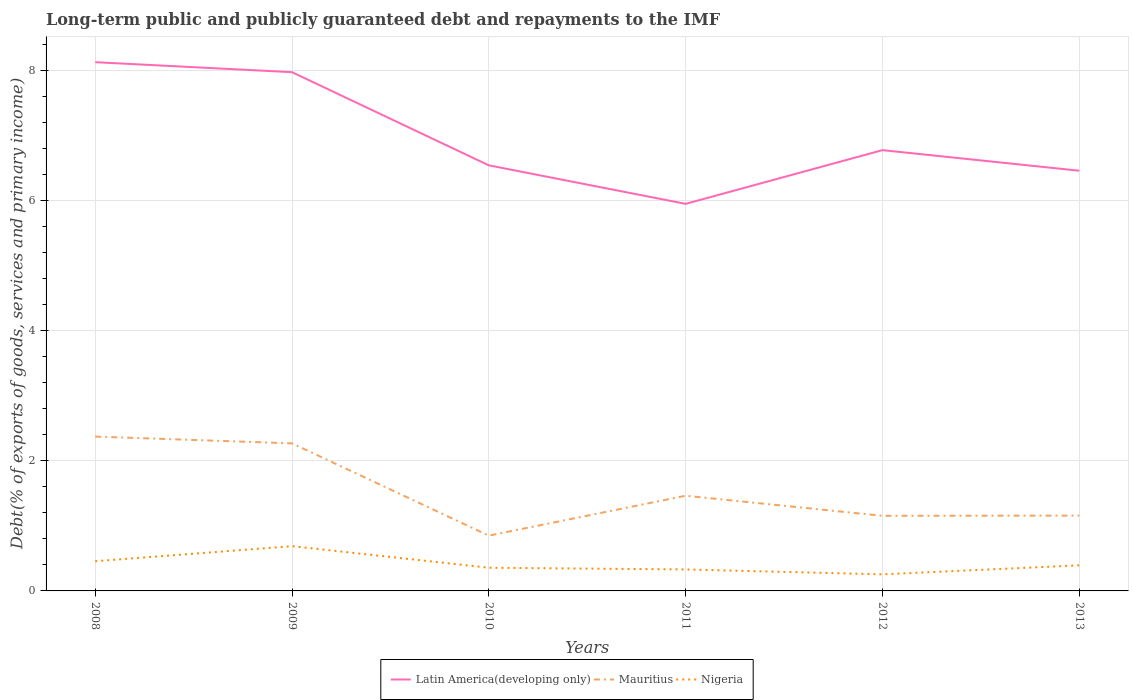Does the line corresponding to Latin America(developing only) intersect with the line corresponding to Mauritius?
Provide a short and direct response. No. Across all years, what is the maximum debt and repayments in Mauritius?
Give a very brief answer. 0.85. In which year was the debt and repayments in Latin America(developing only) maximum?
Make the answer very short. 2011. What is the total debt and repayments in Nigeria in the graph?
Your answer should be compact. 0.1. What is the difference between the highest and the second highest debt and repayments in Nigeria?
Keep it short and to the point. 0.43. Is the debt and repayments in Latin America(developing only) strictly greater than the debt and repayments in Mauritius over the years?
Offer a very short reply. No. How many lines are there?
Make the answer very short. 3. How many years are there in the graph?
Your answer should be compact. 6. Are the values on the major ticks of Y-axis written in scientific E-notation?
Keep it short and to the point. No. Where does the legend appear in the graph?
Keep it short and to the point. Bottom center. How many legend labels are there?
Keep it short and to the point. 3. How are the legend labels stacked?
Provide a short and direct response. Horizontal. What is the title of the graph?
Your answer should be compact. Long-term public and publicly guaranteed debt and repayments to the IMF. Does "Monaco" appear as one of the legend labels in the graph?
Provide a short and direct response. No. What is the label or title of the X-axis?
Give a very brief answer. Years. What is the label or title of the Y-axis?
Your answer should be very brief. Debt(% of exports of goods, services and primary income). What is the Debt(% of exports of goods, services and primary income) in Latin America(developing only) in 2008?
Keep it short and to the point. 8.13. What is the Debt(% of exports of goods, services and primary income) of Mauritius in 2008?
Provide a short and direct response. 2.37. What is the Debt(% of exports of goods, services and primary income) in Nigeria in 2008?
Make the answer very short. 0.46. What is the Debt(% of exports of goods, services and primary income) in Latin America(developing only) in 2009?
Keep it short and to the point. 7.97. What is the Debt(% of exports of goods, services and primary income) of Mauritius in 2009?
Give a very brief answer. 2.27. What is the Debt(% of exports of goods, services and primary income) of Nigeria in 2009?
Offer a terse response. 0.69. What is the Debt(% of exports of goods, services and primary income) of Latin America(developing only) in 2010?
Your answer should be compact. 6.54. What is the Debt(% of exports of goods, services and primary income) of Mauritius in 2010?
Offer a terse response. 0.85. What is the Debt(% of exports of goods, services and primary income) of Nigeria in 2010?
Your answer should be compact. 0.36. What is the Debt(% of exports of goods, services and primary income) of Latin America(developing only) in 2011?
Keep it short and to the point. 5.95. What is the Debt(% of exports of goods, services and primary income) of Mauritius in 2011?
Give a very brief answer. 1.46. What is the Debt(% of exports of goods, services and primary income) of Nigeria in 2011?
Your answer should be compact. 0.33. What is the Debt(% of exports of goods, services and primary income) in Latin America(developing only) in 2012?
Ensure brevity in your answer.  6.78. What is the Debt(% of exports of goods, services and primary income) in Mauritius in 2012?
Your answer should be compact. 1.15. What is the Debt(% of exports of goods, services and primary income) of Nigeria in 2012?
Your response must be concise. 0.25. What is the Debt(% of exports of goods, services and primary income) of Latin America(developing only) in 2013?
Give a very brief answer. 6.46. What is the Debt(% of exports of goods, services and primary income) of Mauritius in 2013?
Offer a very short reply. 1.16. What is the Debt(% of exports of goods, services and primary income) of Nigeria in 2013?
Ensure brevity in your answer.  0.39. Across all years, what is the maximum Debt(% of exports of goods, services and primary income) of Latin America(developing only)?
Give a very brief answer. 8.13. Across all years, what is the maximum Debt(% of exports of goods, services and primary income) in Mauritius?
Your response must be concise. 2.37. Across all years, what is the maximum Debt(% of exports of goods, services and primary income) of Nigeria?
Provide a succinct answer. 0.69. Across all years, what is the minimum Debt(% of exports of goods, services and primary income) of Latin America(developing only)?
Offer a terse response. 5.95. Across all years, what is the minimum Debt(% of exports of goods, services and primary income) of Mauritius?
Your answer should be compact. 0.85. Across all years, what is the minimum Debt(% of exports of goods, services and primary income) of Nigeria?
Ensure brevity in your answer.  0.25. What is the total Debt(% of exports of goods, services and primary income) in Latin America(developing only) in the graph?
Ensure brevity in your answer.  41.83. What is the total Debt(% of exports of goods, services and primary income) in Mauritius in the graph?
Keep it short and to the point. 9.27. What is the total Debt(% of exports of goods, services and primary income) of Nigeria in the graph?
Offer a very short reply. 2.48. What is the difference between the Debt(% of exports of goods, services and primary income) in Latin America(developing only) in 2008 and that in 2009?
Give a very brief answer. 0.15. What is the difference between the Debt(% of exports of goods, services and primary income) of Mauritius in 2008 and that in 2009?
Your response must be concise. 0.1. What is the difference between the Debt(% of exports of goods, services and primary income) in Nigeria in 2008 and that in 2009?
Offer a very short reply. -0.23. What is the difference between the Debt(% of exports of goods, services and primary income) of Latin America(developing only) in 2008 and that in 2010?
Your response must be concise. 1.59. What is the difference between the Debt(% of exports of goods, services and primary income) in Mauritius in 2008 and that in 2010?
Keep it short and to the point. 1.52. What is the difference between the Debt(% of exports of goods, services and primary income) in Nigeria in 2008 and that in 2010?
Ensure brevity in your answer.  0.1. What is the difference between the Debt(% of exports of goods, services and primary income) of Latin America(developing only) in 2008 and that in 2011?
Your response must be concise. 2.18. What is the difference between the Debt(% of exports of goods, services and primary income) in Mauritius in 2008 and that in 2011?
Provide a short and direct response. 0.91. What is the difference between the Debt(% of exports of goods, services and primary income) of Nigeria in 2008 and that in 2011?
Keep it short and to the point. 0.13. What is the difference between the Debt(% of exports of goods, services and primary income) of Latin America(developing only) in 2008 and that in 2012?
Ensure brevity in your answer.  1.35. What is the difference between the Debt(% of exports of goods, services and primary income) of Mauritius in 2008 and that in 2012?
Offer a very short reply. 1.22. What is the difference between the Debt(% of exports of goods, services and primary income) of Nigeria in 2008 and that in 2012?
Make the answer very short. 0.2. What is the difference between the Debt(% of exports of goods, services and primary income) of Latin America(developing only) in 2008 and that in 2013?
Your response must be concise. 1.67. What is the difference between the Debt(% of exports of goods, services and primary income) of Mauritius in 2008 and that in 2013?
Your answer should be compact. 1.21. What is the difference between the Debt(% of exports of goods, services and primary income) in Nigeria in 2008 and that in 2013?
Your answer should be very brief. 0.06. What is the difference between the Debt(% of exports of goods, services and primary income) of Latin America(developing only) in 2009 and that in 2010?
Offer a terse response. 1.43. What is the difference between the Debt(% of exports of goods, services and primary income) in Mauritius in 2009 and that in 2010?
Offer a very short reply. 1.42. What is the difference between the Debt(% of exports of goods, services and primary income) in Nigeria in 2009 and that in 2010?
Your answer should be very brief. 0.33. What is the difference between the Debt(% of exports of goods, services and primary income) of Latin America(developing only) in 2009 and that in 2011?
Offer a terse response. 2.02. What is the difference between the Debt(% of exports of goods, services and primary income) of Mauritius in 2009 and that in 2011?
Give a very brief answer. 0.81. What is the difference between the Debt(% of exports of goods, services and primary income) in Nigeria in 2009 and that in 2011?
Give a very brief answer. 0.36. What is the difference between the Debt(% of exports of goods, services and primary income) of Latin America(developing only) in 2009 and that in 2012?
Provide a short and direct response. 1.2. What is the difference between the Debt(% of exports of goods, services and primary income) of Mauritius in 2009 and that in 2012?
Your answer should be compact. 1.11. What is the difference between the Debt(% of exports of goods, services and primary income) of Nigeria in 2009 and that in 2012?
Provide a short and direct response. 0.43. What is the difference between the Debt(% of exports of goods, services and primary income) in Latin America(developing only) in 2009 and that in 2013?
Your response must be concise. 1.51. What is the difference between the Debt(% of exports of goods, services and primary income) of Mauritius in 2009 and that in 2013?
Your answer should be very brief. 1.11. What is the difference between the Debt(% of exports of goods, services and primary income) in Nigeria in 2009 and that in 2013?
Ensure brevity in your answer.  0.29. What is the difference between the Debt(% of exports of goods, services and primary income) in Latin America(developing only) in 2010 and that in 2011?
Give a very brief answer. 0.59. What is the difference between the Debt(% of exports of goods, services and primary income) in Mauritius in 2010 and that in 2011?
Offer a terse response. -0.61. What is the difference between the Debt(% of exports of goods, services and primary income) of Nigeria in 2010 and that in 2011?
Offer a very short reply. 0.03. What is the difference between the Debt(% of exports of goods, services and primary income) in Latin America(developing only) in 2010 and that in 2012?
Give a very brief answer. -0.23. What is the difference between the Debt(% of exports of goods, services and primary income) in Mauritius in 2010 and that in 2012?
Provide a short and direct response. -0.3. What is the difference between the Debt(% of exports of goods, services and primary income) in Nigeria in 2010 and that in 2012?
Your answer should be compact. 0.1. What is the difference between the Debt(% of exports of goods, services and primary income) of Latin America(developing only) in 2010 and that in 2013?
Provide a short and direct response. 0.08. What is the difference between the Debt(% of exports of goods, services and primary income) of Mauritius in 2010 and that in 2013?
Make the answer very short. -0.31. What is the difference between the Debt(% of exports of goods, services and primary income) in Nigeria in 2010 and that in 2013?
Make the answer very short. -0.04. What is the difference between the Debt(% of exports of goods, services and primary income) in Latin America(developing only) in 2011 and that in 2012?
Give a very brief answer. -0.83. What is the difference between the Debt(% of exports of goods, services and primary income) of Mauritius in 2011 and that in 2012?
Your response must be concise. 0.31. What is the difference between the Debt(% of exports of goods, services and primary income) in Nigeria in 2011 and that in 2012?
Provide a succinct answer. 0.08. What is the difference between the Debt(% of exports of goods, services and primary income) of Latin America(developing only) in 2011 and that in 2013?
Your response must be concise. -0.51. What is the difference between the Debt(% of exports of goods, services and primary income) of Mauritius in 2011 and that in 2013?
Offer a terse response. 0.3. What is the difference between the Debt(% of exports of goods, services and primary income) in Nigeria in 2011 and that in 2013?
Provide a short and direct response. -0.06. What is the difference between the Debt(% of exports of goods, services and primary income) in Latin America(developing only) in 2012 and that in 2013?
Ensure brevity in your answer.  0.32. What is the difference between the Debt(% of exports of goods, services and primary income) in Mauritius in 2012 and that in 2013?
Provide a short and direct response. -0. What is the difference between the Debt(% of exports of goods, services and primary income) of Nigeria in 2012 and that in 2013?
Keep it short and to the point. -0.14. What is the difference between the Debt(% of exports of goods, services and primary income) in Latin America(developing only) in 2008 and the Debt(% of exports of goods, services and primary income) in Mauritius in 2009?
Provide a short and direct response. 5.86. What is the difference between the Debt(% of exports of goods, services and primary income) of Latin America(developing only) in 2008 and the Debt(% of exports of goods, services and primary income) of Nigeria in 2009?
Your answer should be compact. 7.44. What is the difference between the Debt(% of exports of goods, services and primary income) in Mauritius in 2008 and the Debt(% of exports of goods, services and primary income) in Nigeria in 2009?
Your answer should be very brief. 1.68. What is the difference between the Debt(% of exports of goods, services and primary income) of Latin America(developing only) in 2008 and the Debt(% of exports of goods, services and primary income) of Mauritius in 2010?
Offer a very short reply. 7.28. What is the difference between the Debt(% of exports of goods, services and primary income) of Latin America(developing only) in 2008 and the Debt(% of exports of goods, services and primary income) of Nigeria in 2010?
Offer a terse response. 7.77. What is the difference between the Debt(% of exports of goods, services and primary income) of Mauritius in 2008 and the Debt(% of exports of goods, services and primary income) of Nigeria in 2010?
Your response must be concise. 2.02. What is the difference between the Debt(% of exports of goods, services and primary income) of Latin America(developing only) in 2008 and the Debt(% of exports of goods, services and primary income) of Mauritius in 2011?
Your answer should be very brief. 6.66. What is the difference between the Debt(% of exports of goods, services and primary income) in Latin America(developing only) in 2008 and the Debt(% of exports of goods, services and primary income) in Nigeria in 2011?
Ensure brevity in your answer.  7.8. What is the difference between the Debt(% of exports of goods, services and primary income) in Mauritius in 2008 and the Debt(% of exports of goods, services and primary income) in Nigeria in 2011?
Make the answer very short. 2.04. What is the difference between the Debt(% of exports of goods, services and primary income) in Latin America(developing only) in 2008 and the Debt(% of exports of goods, services and primary income) in Mauritius in 2012?
Keep it short and to the point. 6.97. What is the difference between the Debt(% of exports of goods, services and primary income) of Latin America(developing only) in 2008 and the Debt(% of exports of goods, services and primary income) of Nigeria in 2012?
Your answer should be very brief. 7.87. What is the difference between the Debt(% of exports of goods, services and primary income) of Mauritius in 2008 and the Debt(% of exports of goods, services and primary income) of Nigeria in 2012?
Your answer should be very brief. 2.12. What is the difference between the Debt(% of exports of goods, services and primary income) of Latin America(developing only) in 2008 and the Debt(% of exports of goods, services and primary income) of Mauritius in 2013?
Offer a very short reply. 6.97. What is the difference between the Debt(% of exports of goods, services and primary income) of Latin America(developing only) in 2008 and the Debt(% of exports of goods, services and primary income) of Nigeria in 2013?
Offer a terse response. 7.73. What is the difference between the Debt(% of exports of goods, services and primary income) in Mauritius in 2008 and the Debt(% of exports of goods, services and primary income) in Nigeria in 2013?
Ensure brevity in your answer.  1.98. What is the difference between the Debt(% of exports of goods, services and primary income) in Latin America(developing only) in 2009 and the Debt(% of exports of goods, services and primary income) in Mauritius in 2010?
Offer a very short reply. 7.12. What is the difference between the Debt(% of exports of goods, services and primary income) of Latin America(developing only) in 2009 and the Debt(% of exports of goods, services and primary income) of Nigeria in 2010?
Provide a short and direct response. 7.62. What is the difference between the Debt(% of exports of goods, services and primary income) of Mauritius in 2009 and the Debt(% of exports of goods, services and primary income) of Nigeria in 2010?
Your answer should be very brief. 1.91. What is the difference between the Debt(% of exports of goods, services and primary income) of Latin America(developing only) in 2009 and the Debt(% of exports of goods, services and primary income) of Mauritius in 2011?
Ensure brevity in your answer.  6.51. What is the difference between the Debt(% of exports of goods, services and primary income) of Latin America(developing only) in 2009 and the Debt(% of exports of goods, services and primary income) of Nigeria in 2011?
Provide a short and direct response. 7.64. What is the difference between the Debt(% of exports of goods, services and primary income) in Mauritius in 2009 and the Debt(% of exports of goods, services and primary income) in Nigeria in 2011?
Offer a terse response. 1.94. What is the difference between the Debt(% of exports of goods, services and primary income) in Latin America(developing only) in 2009 and the Debt(% of exports of goods, services and primary income) in Mauritius in 2012?
Provide a succinct answer. 6.82. What is the difference between the Debt(% of exports of goods, services and primary income) of Latin America(developing only) in 2009 and the Debt(% of exports of goods, services and primary income) of Nigeria in 2012?
Your answer should be compact. 7.72. What is the difference between the Debt(% of exports of goods, services and primary income) in Mauritius in 2009 and the Debt(% of exports of goods, services and primary income) in Nigeria in 2012?
Give a very brief answer. 2.01. What is the difference between the Debt(% of exports of goods, services and primary income) in Latin America(developing only) in 2009 and the Debt(% of exports of goods, services and primary income) in Mauritius in 2013?
Provide a succinct answer. 6.82. What is the difference between the Debt(% of exports of goods, services and primary income) of Latin America(developing only) in 2009 and the Debt(% of exports of goods, services and primary income) of Nigeria in 2013?
Provide a short and direct response. 7.58. What is the difference between the Debt(% of exports of goods, services and primary income) of Mauritius in 2009 and the Debt(% of exports of goods, services and primary income) of Nigeria in 2013?
Keep it short and to the point. 1.88. What is the difference between the Debt(% of exports of goods, services and primary income) of Latin America(developing only) in 2010 and the Debt(% of exports of goods, services and primary income) of Mauritius in 2011?
Make the answer very short. 5.08. What is the difference between the Debt(% of exports of goods, services and primary income) of Latin America(developing only) in 2010 and the Debt(% of exports of goods, services and primary income) of Nigeria in 2011?
Provide a short and direct response. 6.21. What is the difference between the Debt(% of exports of goods, services and primary income) in Mauritius in 2010 and the Debt(% of exports of goods, services and primary income) in Nigeria in 2011?
Provide a succinct answer. 0.52. What is the difference between the Debt(% of exports of goods, services and primary income) of Latin America(developing only) in 2010 and the Debt(% of exports of goods, services and primary income) of Mauritius in 2012?
Your answer should be compact. 5.39. What is the difference between the Debt(% of exports of goods, services and primary income) of Latin America(developing only) in 2010 and the Debt(% of exports of goods, services and primary income) of Nigeria in 2012?
Your answer should be compact. 6.29. What is the difference between the Debt(% of exports of goods, services and primary income) of Mauritius in 2010 and the Debt(% of exports of goods, services and primary income) of Nigeria in 2012?
Your answer should be compact. 0.59. What is the difference between the Debt(% of exports of goods, services and primary income) of Latin America(developing only) in 2010 and the Debt(% of exports of goods, services and primary income) of Mauritius in 2013?
Your answer should be very brief. 5.38. What is the difference between the Debt(% of exports of goods, services and primary income) of Latin America(developing only) in 2010 and the Debt(% of exports of goods, services and primary income) of Nigeria in 2013?
Make the answer very short. 6.15. What is the difference between the Debt(% of exports of goods, services and primary income) of Mauritius in 2010 and the Debt(% of exports of goods, services and primary income) of Nigeria in 2013?
Offer a terse response. 0.46. What is the difference between the Debt(% of exports of goods, services and primary income) of Latin America(developing only) in 2011 and the Debt(% of exports of goods, services and primary income) of Mauritius in 2012?
Make the answer very short. 4.8. What is the difference between the Debt(% of exports of goods, services and primary income) in Latin America(developing only) in 2011 and the Debt(% of exports of goods, services and primary income) in Nigeria in 2012?
Make the answer very short. 5.69. What is the difference between the Debt(% of exports of goods, services and primary income) of Mauritius in 2011 and the Debt(% of exports of goods, services and primary income) of Nigeria in 2012?
Ensure brevity in your answer.  1.21. What is the difference between the Debt(% of exports of goods, services and primary income) of Latin America(developing only) in 2011 and the Debt(% of exports of goods, services and primary income) of Mauritius in 2013?
Offer a terse response. 4.79. What is the difference between the Debt(% of exports of goods, services and primary income) of Latin America(developing only) in 2011 and the Debt(% of exports of goods, services and primary income) of Nigeria in 2013?
Offer a very short reply. 5.56. What is the difference between the Debt(% of exports of goods, services and primary income) of Mauritius in 2011 and the Debt(% of exports of goods, services and primary income) of Nigeria in 2013?
Make the answer very short. 1.07. What is the difference between the Debt(% of exports of goods, services and primary income) of Latin America(developing only) in 2012 and the Debt(% of exports of goods, services and primary income) of Mauritius in 2013?
Give a very brief answer. 5.62. What is the difference between the Debt(% of exports of goods, services and primary income) in Latin America(developing only) in 2012 and the Debt(% of exports of goods, services and primary income) in Nigeria in 2013?
Provide a short and direct response. 6.38. What is the difference between the Debt(% of exports of goods, services and primary income) in Mauritius in 2012 and the Debt(% of exports of goods, services and primary income) in Nigeria in 2013?
Provide a succinct answer. 0.76. What is the average Debt(% of exports of goods, services and primary income) of Latin America(developing only) per year?
Provide a succinct answer. 6.97. What is the average Debt(% of exports of goods, services and primary income) in Mauritius per year?
Your response must be concise. 1.54. What is the average Debt(% of exports of goods, services and primary income) in Nigeria per year?
Give a very brief answer. 0.41. In the year 2008, what is the difference between the Debt(% of exports of goods, services and primary income) in Latin America(developing only) and Debt(% of exports of goods, services and primary income) in Mauritius?
Keep it short and to the point. 5.76. In the year 2008, what is the difference between the Debt(% of exports of goods, services and primary income) in Latin America(developing only) and Debt(% of exports of goods, services and primary income) in Nigeria?
Offer a very short reply. 7.67. In the year 2008, what is the difference between the Debt(% of exports of goods, services and primary income) in Mauritius and Debt(% of exports of goods, services and primary income) in Nigeria?
Your answer should be very brief. 1.92. In the year 2009, what is the difference between the Debt(% of exports of goods, services and primary income) in Latin America(developing only) and Debt(% of exports of goods, services and primary income) in Mauritius?
Your response must be concise. 5.71. In the year 2009, what is the difference between the Debt(% of exports of goods, services and primary income) in Latin America(developing only) and Debt(% of exports of goods, services and primary income) in Nigeria?
Make the answer very short. 7.29. In the year 2009, what is the difference between the Debt(% of exports of goods, services and primary income) in Mauritius and Debt(% of exports of goods, services and primary income) in Nigeria?
Ensure brevity in your answer.  1.58. In the year 2010, what is the difference between the Debt(% of exports of goods, services and primary income) in Latin America(developing only) and Debt(% of exports of goods, services and primary income) in Mauritius?
Your response must be concise. 5.69. In the year 2010, what is the difference between the Debt(% of exports of goods, services and primary income) in Latin America(developing only) and Debt(% of exports of goods, services and primary income) in Nigeria?
Provide a succinct answer. 6.19. In the year 2010, what is the difference between the Debt(% of exports of goods, services and primary income) in Mauritius and Debt(% of exports of goods, services and primary income) in Nigeria?
Your response must be concise. 0.49. In the year 2011, what is the difference between the Debt(% of exports of goods, services and primary income) in Latin America(developing only) and Debt(% of exports of goods, services and primary income) in Mauritius?
Offer a very short reply. 4.49. In the year 2011, what is the difference between the Debt(% of exports of goods, services and primary income) of Latin America(developing only) and Debt(% of exports of goods, services and primary income) of Nigeria?
Offer a very short reply. 5.62. In the year 2011, what is the difference between the Debt(% of exports of goods, services and primary income) of Mauritius and Debt(% of exports of goods, services and primary income) of Nigeria?
Make the answer very short. 1.13. In the year 2012, what is the difference between the Debt(% of exports of goods, services and primary income) of Latin America(developing only) and Debt(% of exports of goods, services and primary income) of Mauritius?
Your answer should be very brief. 5.62. In the year 2012, what is the difference between the Debt(% of exports of goods, services and primary income) in Latin America(developing only) and Debt(% of exports of goods, services and primary income) in Nigeria?
Offer a terse response. 6.52. In the year 2012, what is the difference between the Debt(% of exports of goods, services and primary income) of Mauritius and Debt(% of exports of goods, services and primary income) of Nigeria?
Give a very brief answer. 0.9. In the year 2013, what is the difference between the Debt(% of exports of goods, services and primary income) in Latin America(developing only) and Debt(% of exports of goods, services and primary income) in Mauritius?
Your answer should be compact. 5.3. In the year 2013, what is the difference between the Debt(% of exports of goods, services and primary income) in Latin America(developing only) and Debt(% of exports of goods, services and primary income) in Nigeria?
Make the answer very short. 6.07. In the year 2013, what is the difference between the Debt(% of exports of goods, services and primary income) in Mauritius and Debt(% of exports of goods, services and primary income) in Nigeria?
Offer a very short reply. 0.76. What is the ratio of the Debt(% of exports of goods, services and primary income) in Latin America(developing only) in 2008 to that in 2009?
Make the answer very short. 1.02. What is the ratio of the Debt(% of exports of goods, services and primary income) in Mauritius in 2008 to that in 2009?
Your answer should be compact. 1.05. What is the ratio of the Debt(% of exports of goods, services and primary income) in Nigeria in 2008 to that in 2009?
Your response must be concise. 0.66. What is the ratio of the Debt(% of exports of goods, services and primary income) of Latin America(developing only) in 2008 to that in 2010?
Offer a very short reply. 1.24. What is the ratio of the Debt(% of exports of goods, services and primary income) of Mauritius in 2008 to that in 2010?
Give a very brief answer. 2.79. What is the ratio of the Debt(% of exports of goods, services and primary income) in Nigeria in 2008 to that in 2010?
Your answer should be very brief. 1.28. What is the ratio of the Debt(% of exports of goods, services and primary income) of Latin America(developing only) in 2008 to that in 2011?
Give a very brief answer. 1.37. What is the ratio of the Debt(% of exports of goods, services and primary income) in Mauritius in 2008 to that in 2011?
Ensure brevity in your answer.  1.62. What is the ratio of the Debt(% of exports of goods, services and primary income) of Nigeria in 2008 to that in 2011?
Your answer should be compact. 1.38. What is the ratio of the Debt(% of exports of goods, services and primary income) of Latin America(developing only) in 2008 to that in 2012?
Offer a terse response. 1.2. What is the ratio of the Debt(% of exports of goods, services and primary income) in Mauritius in 2008 to that in 2012?
Your response must be concise. 2.05. What is the ratio of the Debt(% of exports of goods, services and primary income) in Nigeria in 2008 to that in 2012?
Provide a succinct answer. 1.79. What is the ratio of the Debt(% of exports of goods, services and primary income) in Latin America(developing only) in 2008 to that in 2013?
Offer a very short reply. 1.26. What is the ratio of the Debt(% of exports of goods, services and primary income) of Mauritius in 2008 to that in 2013?
Your response must be concise. 2.05. What is the ratio of the Debt(% of exports of goods, services and primary income) in Nigeria in 2008 to that in 2013?
Give a very brief answer. 1.16. What is the ratio of the Debt(% of exports of goods, services and primary income) of Latin America(developing only) in 2009 to that in 2010?
Provide a short and direct response. 1.22. What is the ratio of the Debt(% of exports of goods, services and primary income) in Mauritius in 2009 to that in 2010?
Provide a short and direct response. 2.67. What is the ratio of the Debt(% of exports of goods, services and primary income) in Nigeria in 2009 to that in 2010?
Give a very brief answer. 1.93. What is the ratio of the Debt(% of exports of goods, services and primary income) of Latin America(developing only) in 2009 to that in 2011?
Offer a terse response. 1.34. What is the ratio of the Debt(% of exports of goods, services and primary income) in Mauritius in 2009 to that in 2011?
Make the answer very short. 1.55. What is the ratio of the Debt(% of exports of goods, services and primary income) in Nigeria in 2009 to that in 2011?
Offer a very short reply. 2.08. What is the ratio of the Debt(% of exports of goods, services and primary income) of Latin America(developing only) in 2009 to that in 2012?
Offer a very short reply. 1.18. What is the ratio of the Debt(% of exports of goods, services and primary income) in Mauritius in 2009 to that in 2012?
Your answer should be compact. 1.96. What is the ratio of the Debt(% of exports of goods, services and primary income) of Nigeria in 2009 to that in 2012?
Keep it short and to the point. 2.7. What is the ratio of the Debt(% of exports of goods, services and primary income) of Latin America(developing only) in 2009 to that in 2013?
Provide a short and direct response. 1.23. What is the ratio of the Debt(% of exports of goods, services and primary income) in Mauritius in 2009 to that in 2013?
Your answer should be very brief. 1.96. What is the ratio of the Debt(% of exports of goods, services and primary income) in Nigeria in 2009 to that in 2013?
Provide a short and direct response. 1.75. What is the ratio of the Debt(% of exports of goods, services and primary income) of Latin America(developing only) in 2010 to that in 2011?
Provide a succinct answer. 1.1. What is the ratio of the Debt(% of exports of goods, services and primary income) of Mauritius in 2010 to that in 2011?
Your answer should be compact. 0.58. What is the ratio of the Debt(% of exports of goods, services and primary income) in Nigeria in 2010 to that in 2011?
Keep it short and to the point. 1.08. What is the ratio of the Debt(% of exports of goods, services and primary income) in Latin America(developing only) in 2010 to that in 2012?
Keep it short and to the point. 0.97. What is the ratio of the Debt(% of exports of goods, services and primary income) of Mauritius in 2010 to that in 2012?
Offer a terse response. 0.74. What is the ratio of the Debt(% of exports of goods, services and primary income) in Nigeria in 2010 to that in 2012?
Provide a succinct answer. 1.4. What is the ratio of the Debt(% of exports of goods, services and primary income) in Latin America(developing only) in 2010 to that in 2013?
Provide a succinct answer. 1.01. What is the ratio of the Debt(% of exports of goods, services and primary income) in Mauritius in 2010 to that in 2013?
Make the answer very short. 0.73. What is the ratio of the Debt(% of exports of goods, services and primary income) of Nigeria in 2010 to that in 2013?
Your answer should be compact. 0.91. What is the ratio of the Debt(% of exports of goods, services and primary income) of Latin America(developing only) in 2011 to that in 2012?
Offer a very short reply. 0.88. What is the ratio of the Debt(% of exports of goods, services and primary income) of Mauritius in 2011 to that in 2012?
Ensure brevity in your answer.  1.27. What is the ratio of the Debt(% of exports of goods, services and primary income) of Nigeria in 2011 to that in 2012?
Your answer should be very brief. 1.3. What is the ratio of the Debt(% of exports of goods, services and primary income) of Latin America(developing only) in 2011 to that in 2013?
Offer a very short reply. 0.92. What is the ratio of the Debt(% of exports of goods, services and primary income) of Mauritius in 2011 to that in 2013?
Give a very brief answer. 1.26. What is the ratio of the Debt(% of exports of goods, services and primary income) of Nigeria in 2011 to that in 2013?
Keep it short and to the point. 0.84. What is the ratio of the Debt(% of exports of goods, services and primary income) of Latin America(developing only) in 2012 to that in 2013?
Your response must be concise. 1.05. What is the ratio of the Debt(% of exports of goods, services and primary income) in Nigeria in 2012 to that in 2013?
Your answer should be very brief. 0.65. What is the difference between the highest and the second highest Debt(% of exports of goods, services and primary income) of Latin America(developing only)?
Your answer should be very brief. 0.15. What is the difference between the highest and the second highest Debt(% of exports of goods, services and primary income) of Mauritius?
Offer a terse response. 0.1. What is the difference between the highest and the second highest Debt(% of exports of goods, services and primary income) in Nigeria?
Offer a very short reply. 0.23. What is the difference between the highest and the lowest Debt(% of exports of goods, services and primary income) in Latin America(developing only)?
Your response must be concise. 2.18. What is the difference between the highest and the lowest Debt(% of exports of goods, services and primary income) of Mauritius?
Your answer should be very brief. 1.52. What is the difference between the highest and the lowest Debt(% of exports of goods, services and primary income) in Nigeria?
Make the answer very short. 0.43. 